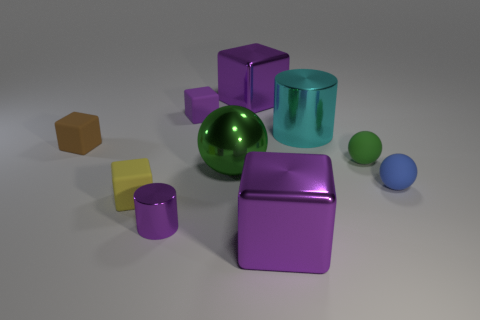What is the color of the cylinder in front of the green matte object?
Your response must be concise. Purple. What shape is the small object that is on the left side of the tiny metal cylinder and in front of the small blue matte sphere?
Make the answer very short. Cube. How many yellow things have the same shape as the brown rubber thing?
Provide a short and direct response. 1. How many tiny yellow matte objects are there?
Provide a succinct answer. 1. What is the size of the sphere that is left of the tiny blue sphere and in front of the small green matte thing?
Keep it short and to the point. Large. There is a yellow object that is the same size as the purple shiny cylinder; what is its shape?
Make the answer very short. Cube. There is a small purple thing to the right of the small purple metal cylinder; are there any green shiny spheres that are in front of it?
Make the answer very short. Yes. There is another metal thing that is the same shape as the blue object; what is its color?
Ensure brevity in your answer.  Green. Is the color of the big block that is in front of the large cyan cylinder the same as the small cylinder?
Give a very brief answer. Yes. How many things are cubes that are right of the tiny brown object or tiny brown rubber cubes?
Your answer should be compact. 5. 